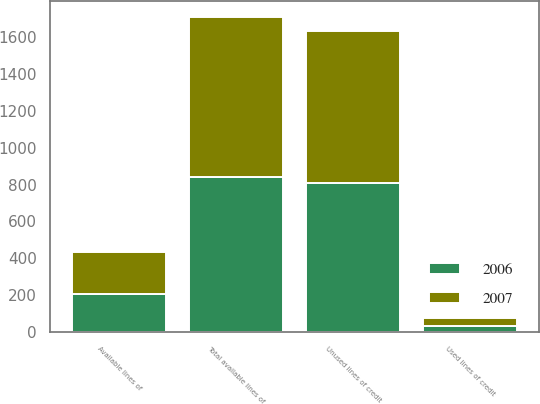<chart> <loc_0><loc_0><loc_500><loc_500><stacked_bar_chart><ecel><fcel>Used lines of credit<fcel>Unused lines of credit<fcel>Total available lines of<fcel>Available lines of<nl><fcel>2007<fcel>46.4<fcel>823.8<fcel>870.2<fcel>224.2<nl><fcel>2006<fcel>30.4<fcel>810.6<fcel>841<fcel>208.1<nl></chart> 